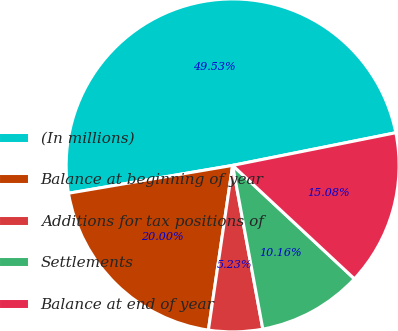Convert chart. <chart><loc_0><loc_0><loc_500><loc_500><pie_chart><fcel>(In millions)<fcel>Balance at beginning of year<fcel>Additions for tax positions of<fcel>Settlements<fcel>Balance at end of year<nl><fcel>49.53%<fcel>20.0%<fcel>5.23%<fcel>10.16%<fcel>15.08%<nl></chart> 